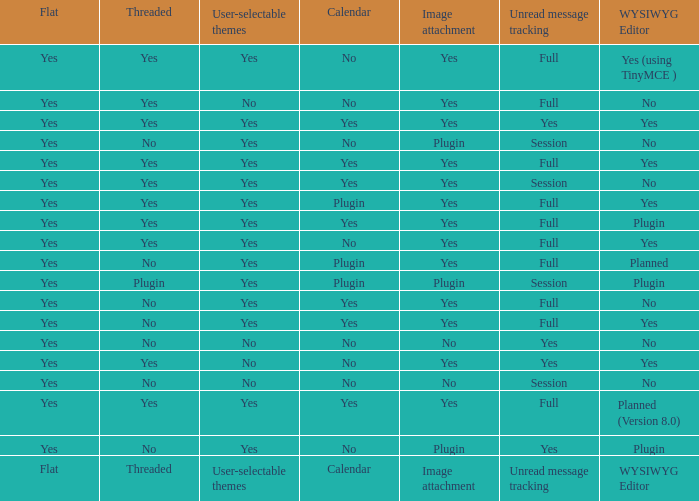Which calendar offers a wysiwyg editor and also tracks unread messages? Yes, No. 